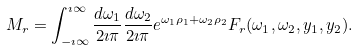Convert formula to latex. <formula><loc_0><loc_0><loc_500><loc_500>M _ { r } = \int _ { - \imath \infty } ^ { \imath \infty } \frac { d \omega _ { 1 } } { 2 \imath \pi } \frac { d \omega _ { 2 } } { 2 \imath \pi } e ^ { \omega _ { 1 } \rho _ { 1 } + \omega _ { 2 } \rho _ { 2 } } F _ { r } ( \omega _ { 1 } , \omega _ { 2 } , y _ { 1 } , y _ { 2 } ) .</formula> 